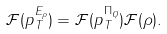<formula> <loc_0><loc_0><loc_500><loc_500>\mathcal { F } ( p _ { T } ^ { E _ { \rho } } ) = \mathcal { F } ( p _ { T } ^ { \Pi _ { Q } } ) \mathcal { F } ( \rho ) .</formula> 